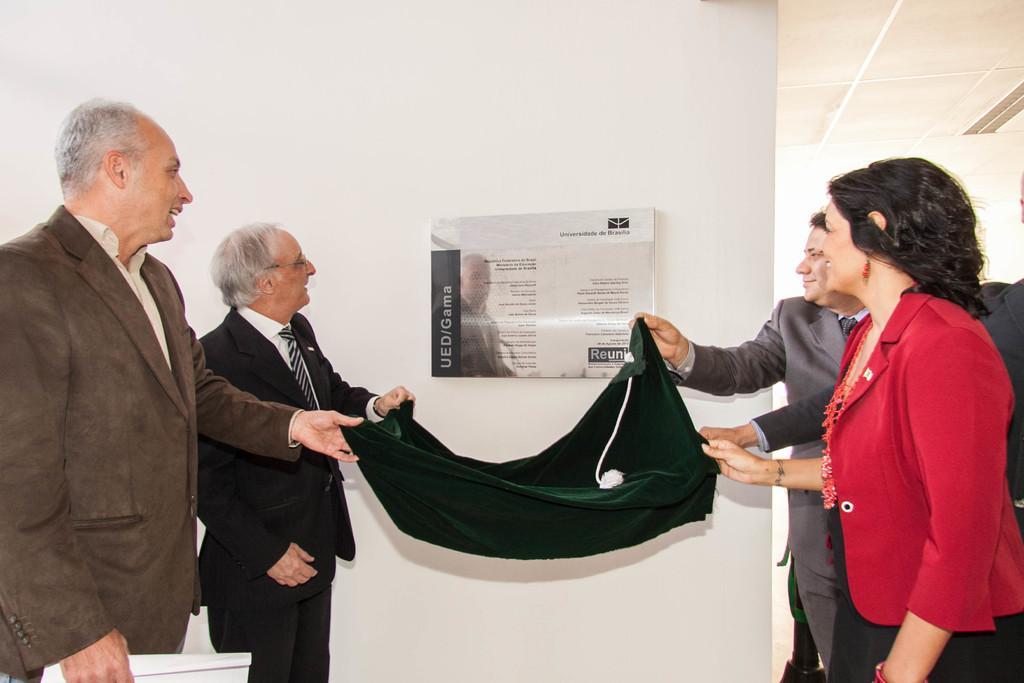Describe this image in one or two sentences. As we can see in the image there is a white color wall, banner and few people over here. They are holding black color cloth. 